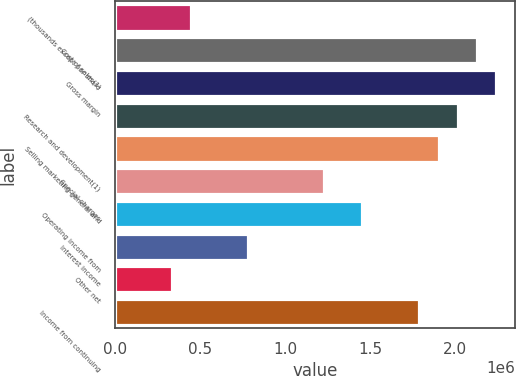Convert chart. <chart><loc_0><loc_0><loc_500><loc_500><bar_chart><fcel>(thousands except per share<fcel>Cost of sales(1)<fcel>Gross margin<fcel>Research and development(1)<fcel>Selling marketing general and<fcel>Special charges<fcel>Operating income from<fcel>Interest income<fcel>Other net<fcel>Income from continuing<nl><fcel>447455<fcel>2.12541e+06<fcel>2.23727e+06<fcel>2.01355e+06<fcel>1.90168e+06<fcel>1.2305e+06<fcel>1.45423e+06<fcel>783046<fcel>335592<fcel>1.78982e+06<nl></chart> 